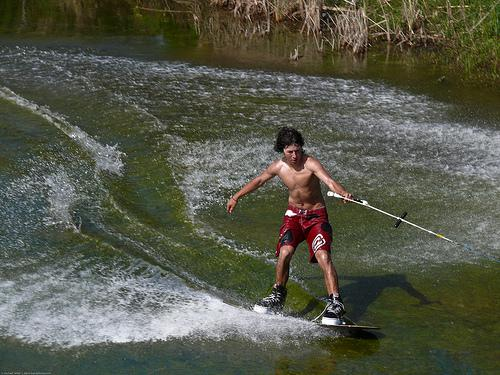Question: who is wakeboarding?
Choices:
A. The girl.
B. The woman.
C. The boy.
D. The man.
Answer with the letter. Answer: D Question: where is the man wakeboarding?
Choices:
A. On the beach.
B. He's not.
C. In the water.
D. On the dock.
Answer with the letter. Answer: C Question: what color is the man's hair?
Choices:
A. Black.
B. Brown.
C. Auburn.
D. Copper.
Answer with the letter. Answer: A Question: what hand is holding the handle?
Choices:
A. Right hand.
B. Left Hand.
C. Both hands.
D. Neither.  It's attached to his waist.
Answer with the letter. Answer: B 